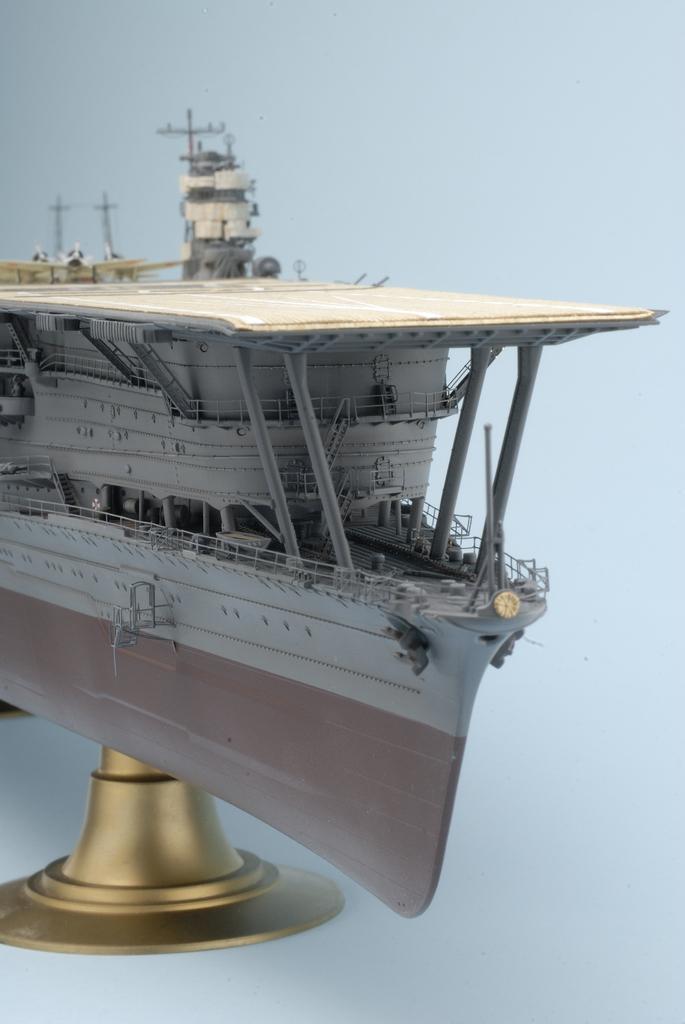Could you give a brief overview of what you see in this image? This is a model of a ship on a stand. On the ship there are railings and pillars. In the background it is light blue. 